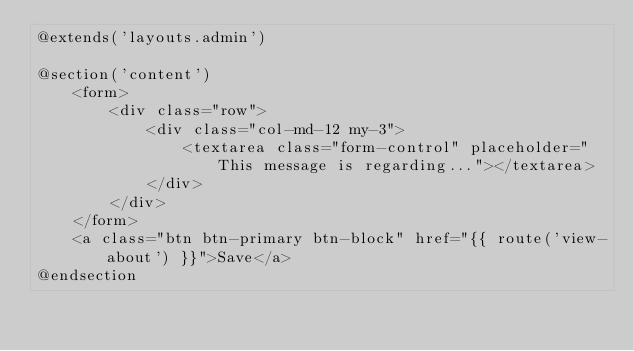Convert code to text. <code><loc_0><loc_0><loc_500><loc_500><_PHP_>@extends('layouts.admin')

@section('content')
    <form>
        <div class="row">
            <div class="col-md-12 my-3">
                <textarea class="form-control" placeholder="This message is regarding..."></textarea>
            </div>
        </div>
    </form>
    <a class="btn btn-primary btn-block" href="{{ route('view-about') }}">Save</a>
@endsection
</code> 